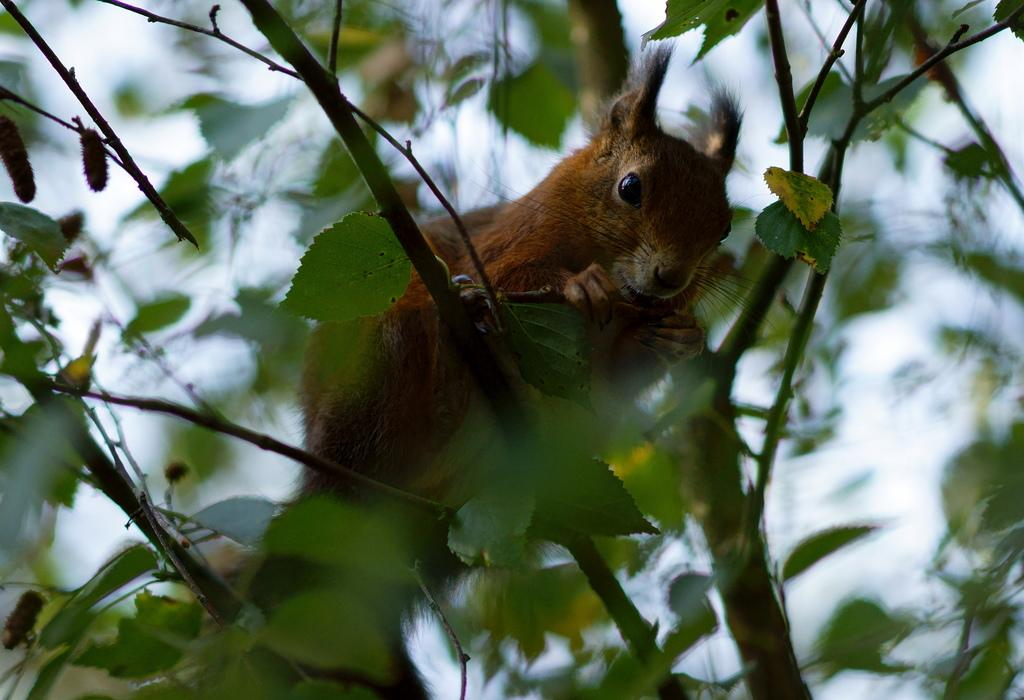What type of animal can be seen in the image? There is an animal in the image, but its specific type cannot be determined from the provided facts. Where is the animal located in the image? The animal is on a branch of a tree in the image. What can be seen in the background of the image? The sky is visible in the background of the image. When was the image likely taken? The image was likely taken during the day, as the sky is visible and there is no indication of darkness. What type of bean is growing on the branch next to the animal in the image? There is no bean plant or bean visible in the image; the animal is on a branch of a tree. Can you see a worm crawling on the animal in the image? There is no worm visible in the image; only the animal on the branch of a tree is present. 